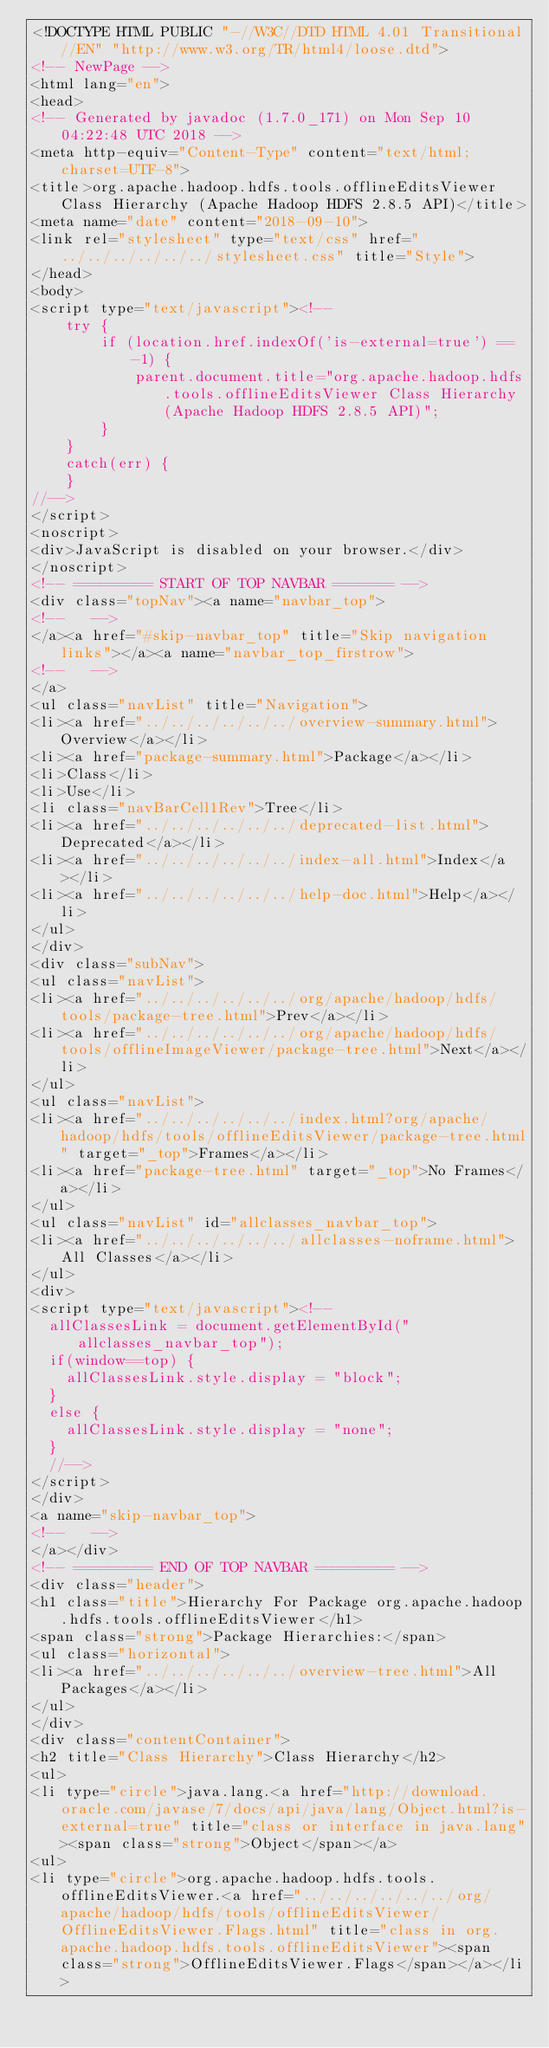<code> <loc_0><loc_0><loc_500><loc_500><_HTML_><!DOCTYPE HTML PUBLIC "-//W3C//DTD HTML 4.01 Transitional//EN" "http://www.w3.org/TR/html4/loose.dtd">
<!-- NewPage -->
<html lang="en">
<head>
<!-- Generated by javadoc (1.7.0_171) on Mon Sep 10 04:22:48 UTC 2018 -->
<meta http-equiv="Content-Type" content="text/html; charset=UTF-8">
<title>org.apache.hadoop.hdfs.tools.offlineEditsViewer Class Hierarchy (Apache Hadoop HDFS 2.8.5 API)</title>
<meta name="date" content="2018-09-10">
<link rel="stylesheet" type="text/css" href="../../../../../../stylesheet.css" title="Style">
</head>
<body>
<script type="text/javascript"><!--
    try {
        if (location.href.indexOf('is-external=true') == -1) {
            parent.document.title="org.apache.hadoop.hdfs.tools.offlineEditsViewer Class Hierarchy (Apache Hadoop HDFS 2.8.5 API)";
        }
    }
    catch(err) {
    }
//-->
</script>
<noscript>
<div>JavaScript is disabled on your browser.</div>
</noscript>
<!-- ========= START OF TOP NAVBAR ======= -->
<div class="topNav"><a name="navbar_top">
<!--   -->
</a><a href="#skip-navbar_top" title="Skip navigation links"></a><a name="navbar_top_firstrow">
<!--   -->
</a>
<ul class="navList" title="Navigation">
<li><a href="../../../../../../overview-summary.html">Overview</a></li>
<li><a href="package-summary.html">Package</a></li>
<li>Class</li>
<li>Use</li>
<li class="navBarCell1Rev">Tree</li>
<li><a href="../../../../../../deprecated-list.html">Deprecated</a></li>
<li><a href="../../../../../../index-all.html">Index</a></li>
<li><a href="../../../../../../help-doc.html">Help</a></li>
</ul>
</div>
<div class="subNav">
<ul class="navList">
<li><a href="../../../../../../org/apache/hadoop/hdfs/tools/package-tree.html">Prev</a></li>
<li><a href="../../../../../../org/apache/hadoop/hdfs/tools/offlineImageViewer/package-tree.html">Next</a></li>
</ul>
<ul class="navList">
<li><a href="../../../../../../index.html?org/apache/hadoop/hdfs/tools/offlineEditsViewer/package-tree.html" target="_top">Frames</a></li>
<li><a href="package-tree.html" target="_top">No Frames</a></li>
</ul>
<ul class="navList" id="allclasses_navbar_top">
<li><a href="../../../../../../allclasses-noframe.html">All Classes</a></li>
</ul>
<div>
<script type="text/javascript"><!--
  allClassesLink = document.getElementById("allclasses_navbar_top");
  if(window==top) {
    allClassesLink.style.display = "block";
  }
  else {
    allClassesLink.style.display = "none";
  }
  //-->
</script>
</div>
<a name="skip-navbar_top">
<!--   -->
</a></div>
<!-- ========= END OF TOP NAVBAR ========= -->
<div class="header">
<h1 class="title">Hierarchy For Package org.apache.hadoop.hdfs.tools.offlineEditsViewer</h1>
<span class="strong">Package Hierarchies:</span>
<ul class="horizontal">
<li><a href="../../../../../../overview-tree.html">All Packages</a></li>
</ul>
</div>
<div class="contentContainer">
<h2 title="Class Hierarchy">Class Hierarchy</h2>
<ul>
<li type="circle">java.lang.<a href="http://download.oracle.com/javase/7/docs/api/java/lang/Object.html?is-external=true" title="class or interface in java.lang"><span class="strong">Object</span></a>
<ul>
<li type="circle">org.apache.hadoop.hdfs.tools.offlineEditsViewer.<a href="../../../../../../org/apache/hadoop/hdfs/tools/offlineEditsViewer/OfflineEditsViewer.Flags.html" title="class in org.apache.hadoop.hdfs.tools.offlineEditsViewer"><span class="strong">OfflineEditsViewer.Flags</span></a></li></code> 